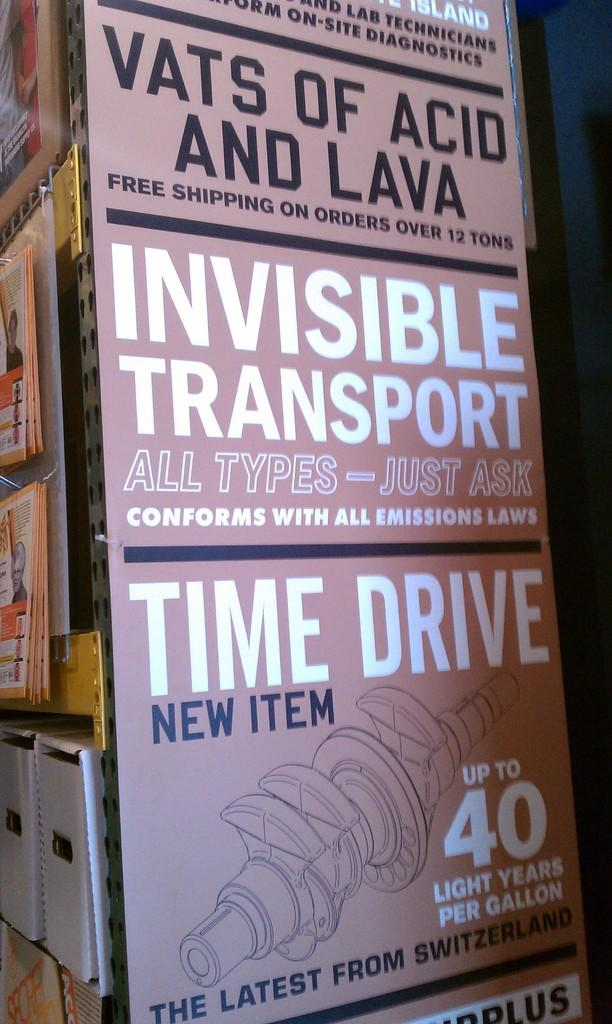<image>
Relay a brief, clear account of the picture shown. A large sign offers free shipping on acid and lava. 